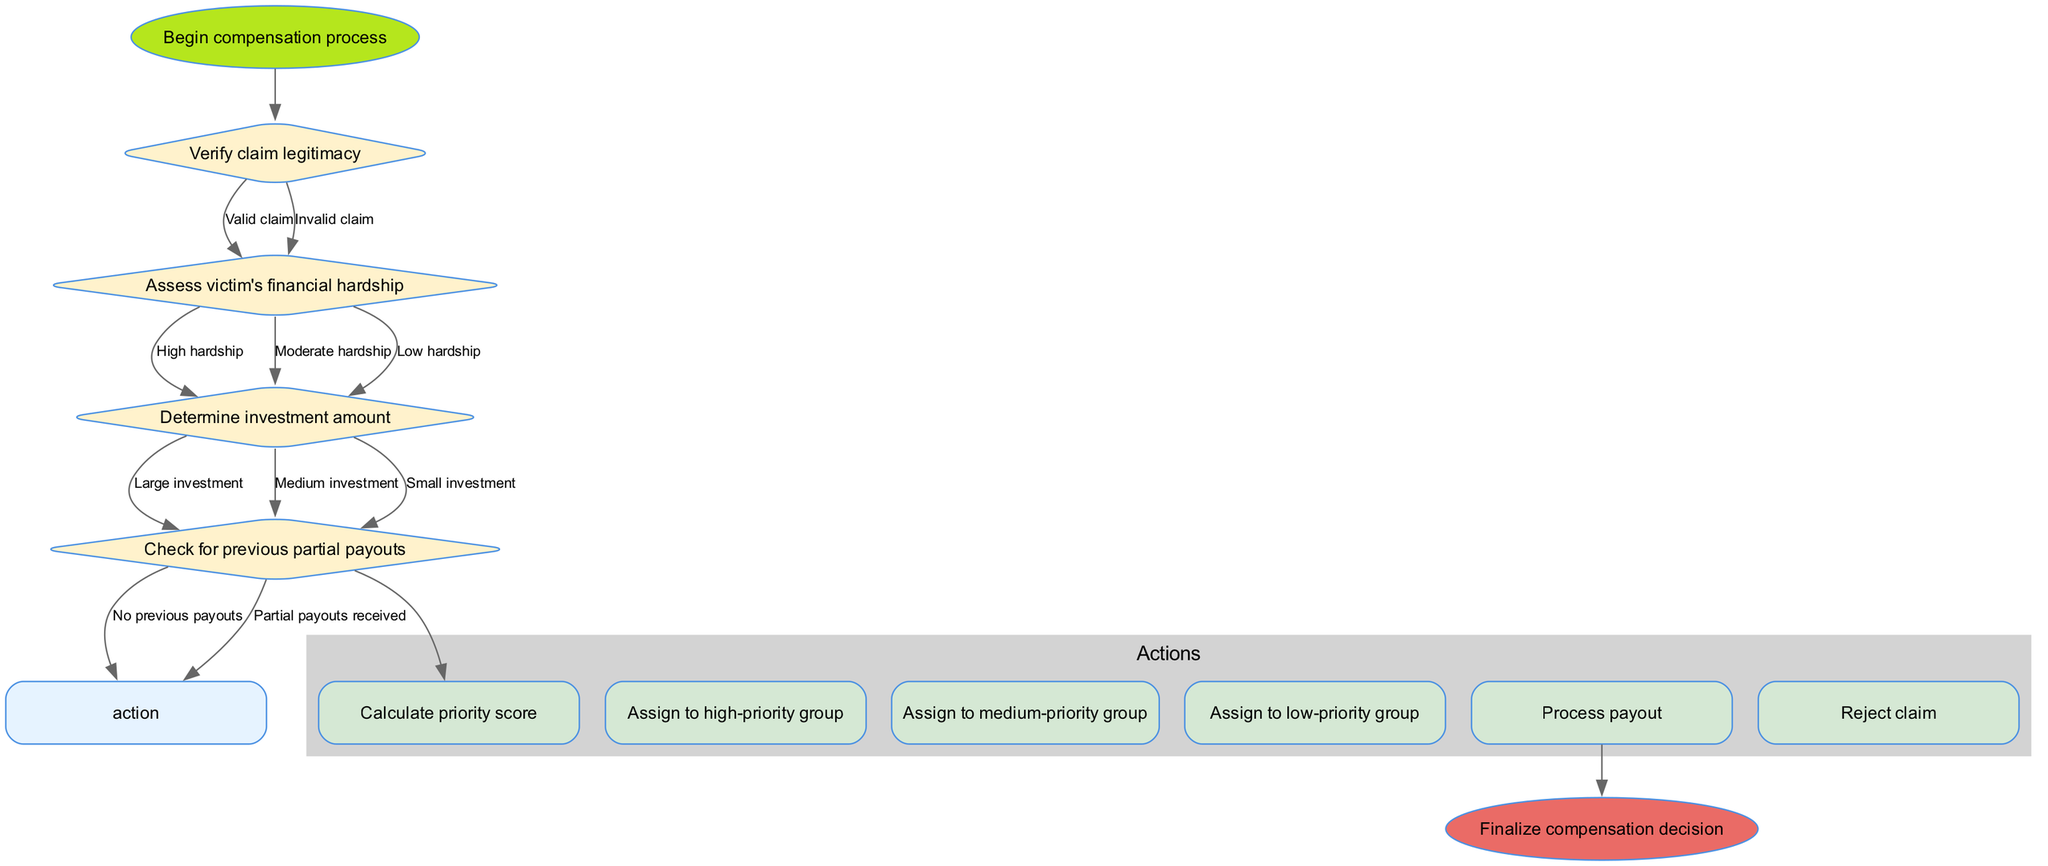What is the first decision node in the flowchart? The first decision node is labeled "Verify claim legitimacy". This can be identified by observing the order in which the decision nodes are connected, starting from the "start" node.
Answer: Verify claim legitimacy Which edge leads to the action node "Process payout"? The edge leading to "Process payout" comes from the last decision node "Check for previous partial payouts" when the outcome is "No previous payouts". This signifies that if there are no prior payouts, the flow proceeds to process the payout.
Answer: No previous payouts How many decision nodes are present in the flowchart? The flowchart contains a total of four decision nodes as listed: "Verify claim legitimacy", "Assess victim's financial hardship", "Determine investment amount", and "Check for previous partial payouts".
Answer: 4 What happens after a claim is rejected? Once a claim is rejected, there is no further action indicated in the flowchart, leading to an endpoint. This state is derived from the outcome of the decision nodes since there’s no edge connecting to any actions from "Invalid claim".
Answer: End If a victim is assessed with "High hardship" and "Large investment", which priority group will they be assigned to? The victim will be assigned to the "high-priority group" since both "High hardship" and "Large investment" indicate a greater need for attention and compensation. This inference is based on the defined actions following those assessments.
Answer: High-priority group Which action follows after calculating the priority score? The action that follows after calculating the priority score is "Assign to high-priority group." This is because the flow progresses to assign the calculated scores into one of the priority groups based on the results from the assessments.
Answer: Assign to high-priority group What is the last action taken in the flowchart? The last action taken in the flowchart is "Process payout". After determining the victim’s priority grouping, processing the distribution of funds is the final step before concluding with the end node.
Answer: Process payout Which decision node assesses the financial situation of victims? The decision node that assesses the financial situation of victims is labeled "Assess victim's financial hardship". It is structured to evaluate the level of hardship that impacts their claims' outcomes.
Answer: Assess victim's financial hardship What node is connected to the start node? The node connected to the start node is "Verify claim legitimacy". This is the first node in the sequence that leads to critical evaluations regarding the legitimacy of the claims before proceeding further.
Answer: Verify claim legitimacy 